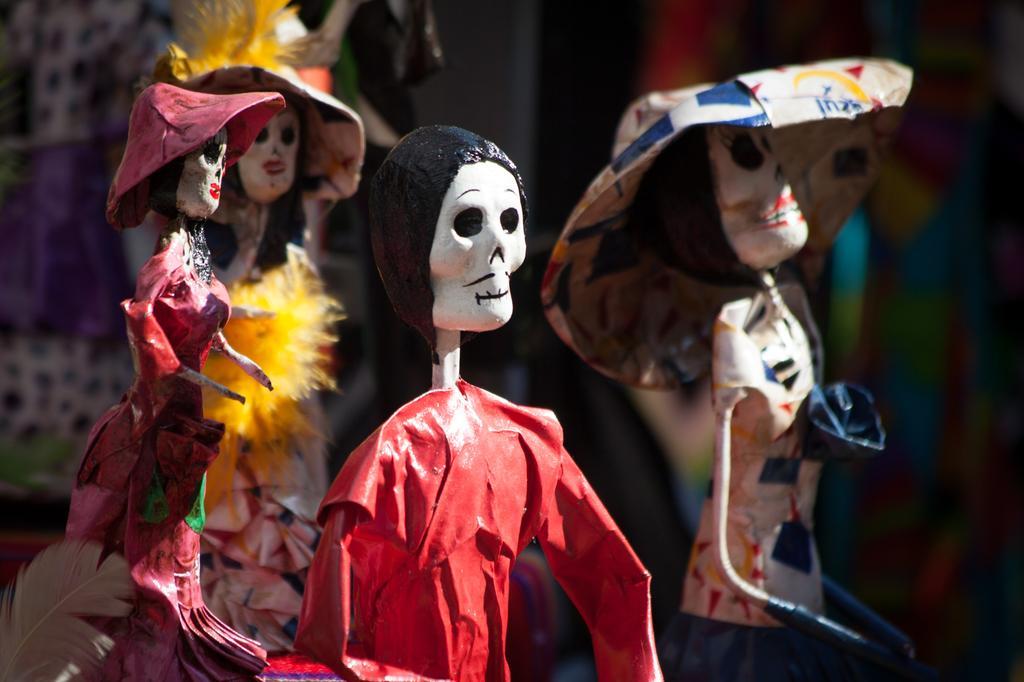What type of material are the toys made of in the image? The toys in the image are made of clay. Can you describe the location of the red toy in the image? The red toy is in the center of the image. Are there any toys with specific accessories in the image? Yes, there are toys with hats in the image. What type of copper material is used to make the goat in the image? There is no goat or copper material present in the image; the toys are made of clay. What event is taking place in the image? There is no event depicted in the image; it simply shows clay toys. 